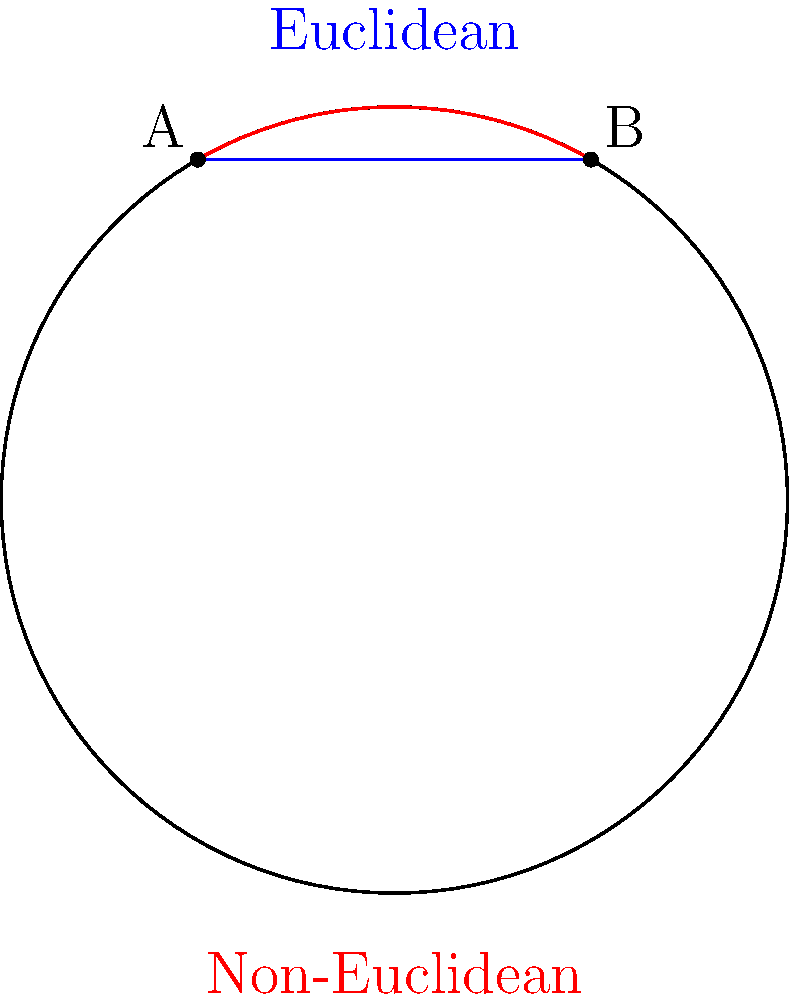On a sphere with radius $R$, two points A and B are separated by an angle $\theta$ (in radians) at the center. If the Euclidean distance between A and B is $d$, what is the ratio of the non-Euclidean (great circle) distance to the Euclidean distance? Let's approach this step-by-step:

1) The Euclidean distance $d$ between A and B is given by the chord length:
   $$d = 2R \sin(\frac{\theta}{2})$$

2) The non-Euclidean distance $s$ (along the great circle) is given by the arc length:
   $$s = R\theta$$

3) The ratio we're looking for is:
   $$\frac{s}{d} = \frac{R\theta}{2R \sin(\frac{\theta}{2})} = \frac{\theta}{2 \sin(\frac{\theta}{2})}$$

4) This ratio is always greater than or equal to 1, because the arc length is always greater than or equal to the chord length.

5) As $\theta$ approaches 0, this ratio approaches 1, because for small angles, the arc length and chord length are nearly the same.

6) As $\theta$ increases, this ratio increases, reflecting the fact that the difference between arc length and chord length becomes more pronounced on a curved surface.
Answer: $\frac{\theta}{2 \sin(\frac{\theta}{2})}$ 